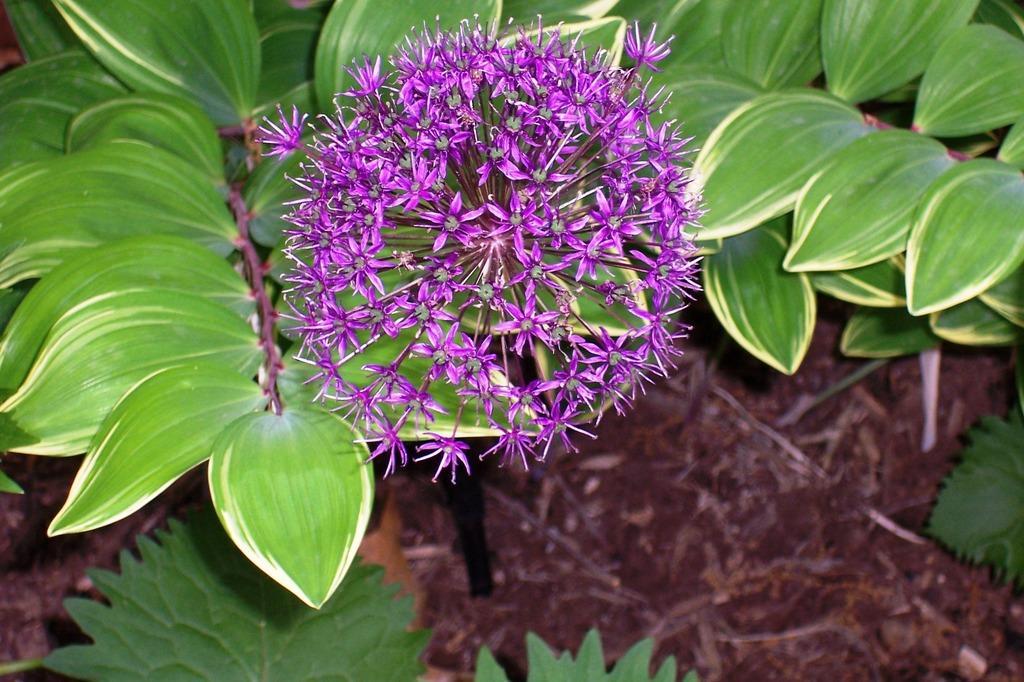Can you describe this image briefly? In this picture I can see that there are a bunch of flowers and there is a plant and there are many leaves and there is soil on the floor. 